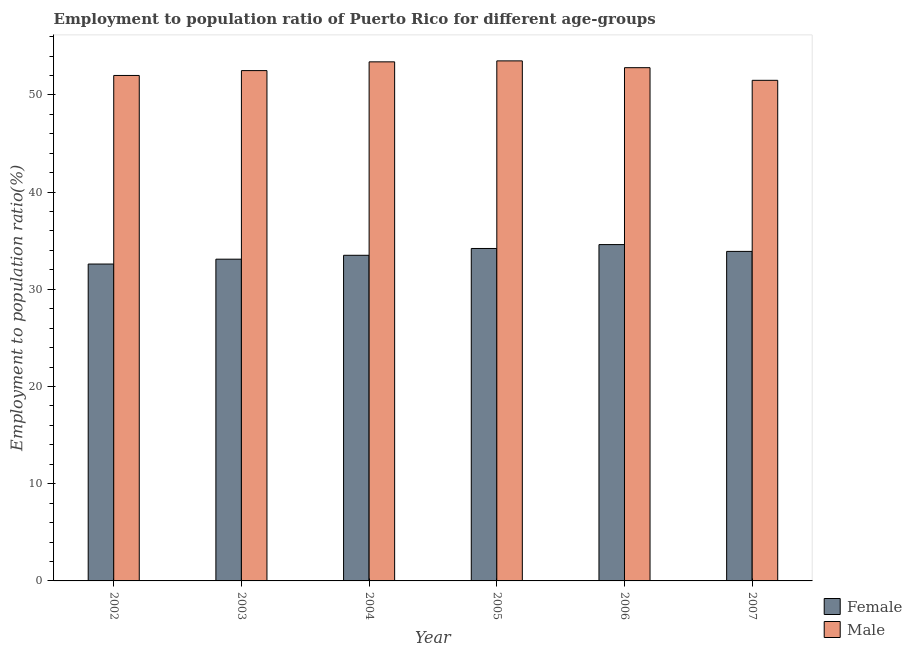How many groups of bars are there?
Your answer should be compact. 6. How many bars are there on the 1st tick from the left?
Provide a succinct answer. 2. What is the employment to population ratio(female) in 2004?
Your answer should be compact. 33.5. Across all years, what is the maximum employment to population ratio(female)?
Your response must be concise. 34.6. Across all years, what is the minimum employment to population ratio(male)?
Provide a succinct answer. 51.5. In which year was the employment to population ratio(female) maximum?
Offer a very short reply. 2006. In which year was the employment to population ratio(male) minimum?
Provide a short and direct response. 2007. What is the total employment to population ratio(female) in the graph?
Make the answer very short. 201.9. What is the difference between the employment to population ratio(male) in 2005 and that in 2007?
Your answer should be very brief. 2. What is the difference between the employment to population ratio(male) in 2006 and the employment to population ratio(female) in 2004?
Provide a succinct answer. -0.6. What is the average employment to population ratio(female) per year?
Ensure brevity in your answer.  33.65. In how many years, is the employment to population ratio(male) greater than 24 %?
Your response must be concise. 6. What is the ratio of the employment to population ratio(female) in 2002 to that in 2007?
Make the answer very short. 0.96. Is the difference between the employment to population ratio(female) in 2004 and 2006 greater than the difference between the employment to population ratio(male) in 2004 and 2006?
Provide a succinct answer. No. What is the difference between the highest and the second highest employment to population ratio(male)?
Your answer should be compact. 0.1. In how many years, is the employment to population ratio(male) greater than the average employment to population ratio(male) taken over all years?
Your response must be concise. 3. What does the 1st bar from the left in 2005 represents?
Your answer should be very brief. Female. How many bars are there?
Offer a terse response. 12. Are all the bars in the graph horizontal?
Your answer should be compact. No. How many years are there in the graph?
Give a very brief answer. 6. What is the difference between two consecutive major ticks on the Y-axis?
Offer a terse response. 10. Does the graph contain any zero values?
Your response must be concise. No. Does the graph contain grids?
Offer a terse response. No. What is the title of the graph?
Offer a terse response. Employment to population ratio of Puerto Rico for different age-groups. What is the Employment to population ratio(%) in Female in 2002?
Offer a very short reply. 32.6. What is the Employment to population ratio(%) of Female in 2003?
Offer a terse response. 33.1. What is the Employment to population ratio(%) in Male in 2003?
Provide a short and direct response. 52.5. What is the Employment to population ratio(%) of Female in 2004?
Make the answer very short. 33.5. What is the Employment to population ratio(%) of Male in 2004?
Ensure brevity in your answer.  53.4. What is the Employment to population ratio(%) in Female in 2005?
Your answer should be very brief. 34.2. What is the Employment to population ratio(%) in Male in 2005?
Offer a very short reply. 53.5. What is the Employment to population ratio(%) of Female in 2006?
Offer a terse response. 34.6. What is the Employment to population ratio(%) in Male in 2006?
Offer a terse response. 52.8. What is the Employment to population ratio(%) of Female in 2007?
Ensure brevity in your answer.  33.9. What is the Employment to population ratio(%) of Male in 2007?
Ensure brevity in your answer.  51.5. Across all years, what is the maximum Employment to population ratio(%) in Female?
Give a very brief answer. 34.6. Across all years, what is the maximum Employment to population ratio(%) in Male?
Offer a very short reply. 53.5. Across all years, what is the minimum Employment to population ratio(%) in Female?
Provide a succinct answer. 32.6. Across all years, what is the minimum Employment to population ratio(%) of Male?
Offer a terse response. 51.5. What is the total Employment to population ratio(%) in Female in the graph?
Make the answer very short. 201.9. What is the total Employment to population ratio(%) of Male in the graph?
Your answer should be compact. 315.7. What is the difference between the Employment to population ratio(%) in Female in 2002 and that in 2003?
Your answer should be compact. -0.5. What is the difference between the Employment to population ratio(%) of Male in 2002 and that in 2004?
Give a very brief answer. -1.4. What is the difference between the Employment to population ratio(%) in Female in 2002 and that in 2005?
Your answer should be compact. -1.6. What is the difference between the Employment to population ratio(%) of Female in 2002 and that in 2006?
Keep it short and to the point. -2. What is the difference between the Employment to population ratio(%) of Female in 2002 and that in 2007?
Your answer should be compact. -1.3. What is the difference between the Employment to population ratio(%) in Male in 2003 and that in 2004?
Your answer should be compact. -0.9. What is the difference between the Employment to population ratio(%) of Male in 2003 and that in 2007?
Provide a succinct answer. 1. What is the difference between the Employment to population ratio(%) in Female in 2004 and that in 2006?
Ensure brevity in your answer.  -1.1. What is the difference between the Employment to population ratio(%) in Male in 2004 and that in 2006?
Ensure brevity in your answer.  0.6. What is the difference between the Employment to population ratio(%) in Female in 2004 and that in 2007?
Make the answer very short. -0.4. What is the difference between the Employment to population ratio(%) of Male in 2004 and that in 2007?
Your answer should be compact. 1.9. What is the difference between the Employment to population ratio(%) of Female in 2005 and that in 2006?
Your answer should be very brief. -0.4. What is the difference between the Employment to population ratio(%) of Female in 2005 and that in 2007?
Your answer should be compact. 0.3. What is the difference between the Employment to population ratio(%) in Male in 2005 and that in 2007?
Give a very brief answer. 2. What is the difference between the Employment to population ratio(%) of Female in 2002 and the Employment to population ratio(%) of Male in 2003?
Provide a short and direct response. -19.9. What is the difference between the Employment to population ratio(%) of Female in 2002 and the Employment to population ratio(%) of Male in 2004?
Give a very brief answer. -20.8. What is the difference between the Employment to population ratio(%) in Female in 2002 and the Employment to population ratio(%) in Male in 2005?
Keep it short and to the point. -20.9. What is the difference between the Employment to population ratio(%) in Female in 2002 and the Employment to population ratio(%) in Male in 2006?
Give a very brief answer. -20.2. What is the difference between the Employment to population ratio(%) of Female in 2002 and the Employment to population ratio(%) of Male in 2007?
Your answer should be compact. -18.9. What is the difference between the Employment to population ratio(%) in Female in 2003 and the Employment to population ratio(%) in Male in 2004?
Make the answer very short. -20.3. What is the difference between the Employment to population ratio(%) in Female in 2003 and the Employment to population ratio(%) in Male in 2005?
Ensure brevity in your answer.  -20.4. What is the difference between the Employment to population ratio(%) of Female in 2003 and the Employment to population ratio(%) of Male in 2006?
Keep it short and to the point. -19.7. What is the difference between the Employment to population ratio(%) of Female in 2003 and the Employment to population ratio(%) of Male in 2007?
Your response must be concise. -18.4. What is the difference between the Employment to population ratio(%) of Female in 2004 and the Employment to population ratio(%) of Male in 2006?
Your answer should be very brief. -19.3. What is the difference between the Employment to population ratio(%) of Female in 2005 and the Employment to population ratio(%) of Male in 2006?
Ensure brevity in your answer.  -18.6. What is the difference between the Employment to population ratio(%) in Female in 2005 and the Employment to population ratio(%) in Male in 2007?
Your response must be concise. -17.3. What is the difference between the Employment to population ratio(%) in Female in 2006 and the Employment to population ratio(%) in Male in 2007?
Your answer should be compact. -16.9. What is the average Employment to population ratio(%) in Female per year?
Provide a short and direct response. 33.65. What is the average Employment to population ratio(%) in Male per year?
Keep it short and to the point. 52.62. In the year 2002, what is the difference between the Employment to population ratio(%) in Female and Employment to population ratio(%) in Male?
Provide a short and direct response. -19.4. In the year 2003, what is the difference between the Employment to population ratio(%) in Female and Employment to population ratio(%) in Male?
Make the answer very short. -19.4. In the year 2004, what is the difference between the Employment to population ratio(%) in Female and Employment to population ratio(%) in Male?
Ensure brevity in your answer.  -19.9. In the year 2005, what is the difference between the Employment to population ratio(%) of Female and Employment to population ratio(%) of Male?
Give a very brief answer. -19.3. In the year 2006, what is the difference between the Employment to population ratio(%) of Female and Employment to population ratio(%) of Male?
Your answer should be very brief. -18.2. In the year 2007, what is the difference between the Employment to population ratio(%) of Female and Employment to population ratio(%) of Male?
Make the answer very short. -17.6. What is the ratio of the Employment to population ratio(%) in Female in 2002 to that in 2003?
Keep it short and to the point. 0.98. What is the ratio of the Employment to population ratio(%) in Male in 2002 to that in 2003?
Offer a very short reply. 0.99. What is the ratio of the Employment to population ratio(%) of Female in 2002 to that in 2004?
Provide a succinct answer. 0.97. What is the ratio of the Employment to population ratio(%) of Male in 2002 to that in 2004?
Make the answer very short. 0.97. What is the ratio of the Employment to population ratio(%) in Female in 2002 to that in 2005?
Give a very brief answer. 0.95. What is the ratio of the Employment to population ratio(%) of Female in 2002 to that in 2006?
Make the answer very short. 0.94. What is the ratio of the Employment to population ratio(%) of Male in 2002 to that in 2006?
Provide a succinct answer. 0.98. What is the ratio of the Employment to population ratio(%) in Female in 2002 to that in 2007?
Ensure brevity in your answer.  0.96. What is the ratio of the Employment to population ratio(%) of Male in 2002 to that in 2007?
Keep it short and to the point. 1.01. What is the ratio of the Employment to population ratio(%) of Female in 2003 to that in 2004?
Offer a very short reply. 0.99. What is the ratio of the Employment to population ratio(%) in Male in 2003 to that in 2004?
Provide a succinct answer. 0.98. What is the ratio of the Employment to population ratio(%) of Female in 2003 to that in 2005?
Your answer should be very brief. 0.97. What is the ratio of the Employment to population ratio(%) in Male in 2003 to that in 2005?
Offer a very short reply. 0.98. What is the ratio of the Employment to population ratio(%) of Female in 2003 to that in 2006?
Provide a succinct answer. 0.96. What is the ratio of the Employment to population ratio(%) in Male in 2003 to that in 2006?
Ensure brevity in your answer.  0.99. What is the ratio of the Employment to population ratio(%) in Female in 2003 to that in 2007?
Ensure brevity in your answer.  0.98. What is the ratio of the Employment to population ratio(%) of Male in 2003 to that in 2007?
Give a very brief answer. 1.02. What is the ratio of the Employment to population ratio(%) in Female in 2004 to that in 2005?
Your answer should be very brief. 0.98. What is the ratio of the Employment to population ratio(%) of Female in 2004 to that in 2006?
Your answer should be compact. 0.97. What is the ratio of the Employment to population ratio(%) in Male in 2004 to that in 2006?
Provide a short and direct response. 1.01. What is the ratio of the Employment to population ratio(%) of Male in 2004 to that in 2007?
Offer a terse response. 1.04. What is the ratio of the Employment to population ratio(%) of Female in 2005 to that in 2006?
Provide a succinct answer. 0.99. What is the ratio of the Employment to population ratio(%) in Male in 2005 to that in 2006?
Offer a terse response. 1.01. What is the ratio of the Employment to population ratio(%) of Female in 2005 to that in 2007?
Offer a terse response. 1.01. What is the ratio of the Employment to population ratio(%) of Male in 2005 to that in 2007?
Your response must be concise. 1.04. What is the ratio of the Employment to population ratio(%) of Female in 2006 to that in 2007?
Your answer should be very brief. 1.02. What is the ratio of the Employment to population ratio(%) in Male in 2006 to that in 2007?
Your response must be concise. 1.03. What is the difference between the highest and the lowest Employment to population ratio(%) in Male?
Offer a very short reply. 2. 